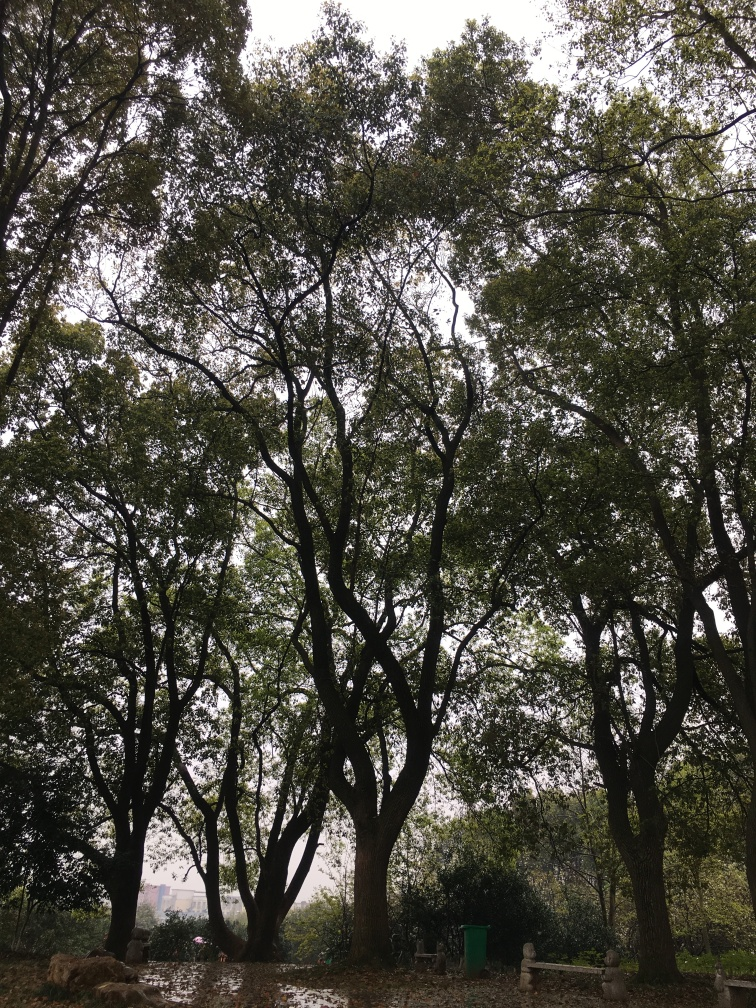Are there any notable features about the trees or the foliage seen here? Yes, the trees have a robust and mature look with thick trunks and dense canopies, indicating they might be quite old. The foliage is lush and green, which could mean the area is well-tended or that it benefits from a healthy natural environment. 